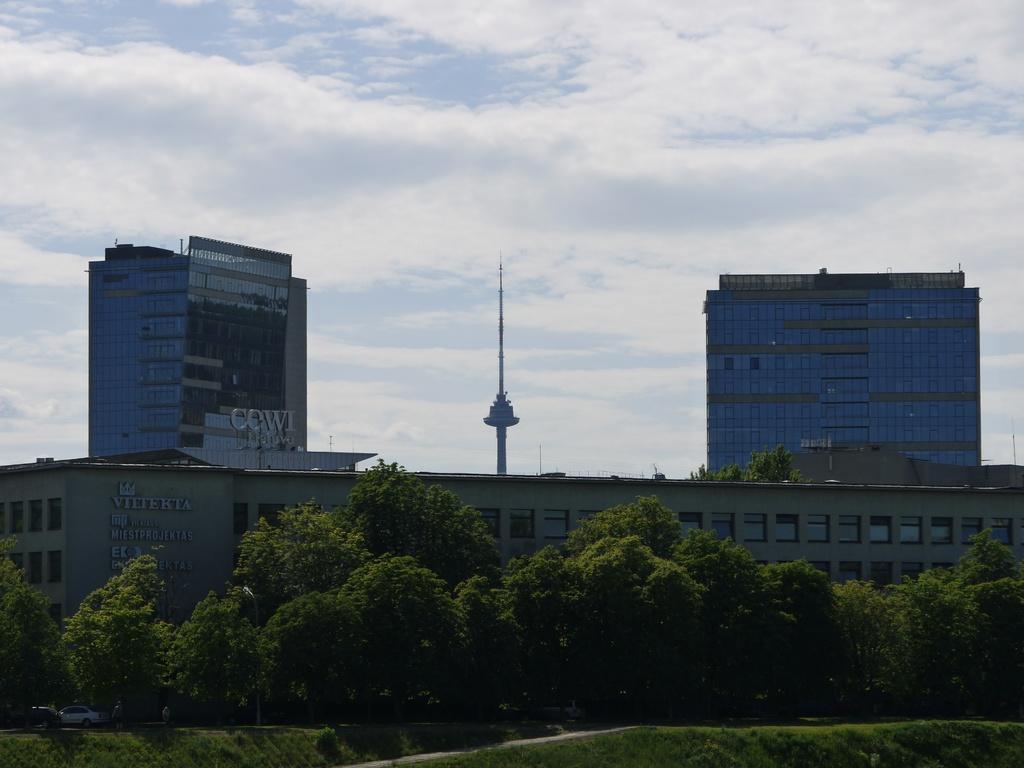Describe this image in one or two sentences. In the foreground of the picture there are trees and grass. In the center of the picture there are buildings and trees. In the background it is sky, sky is cloudy. 